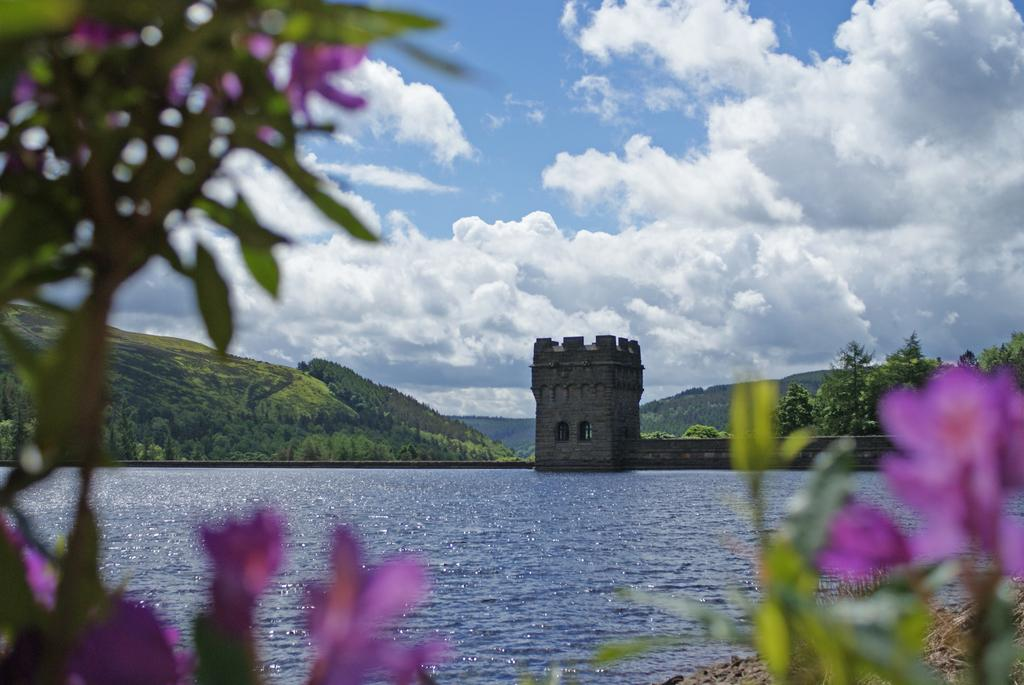What is the primary element visible in the image? There is water in the image. What types of plants can be seen in the foreground? There are flowers and leaves in the foreground. What type of landscape can be seen in the background? There are mountains in the background. Are there any man-made structures visible in the image? Yes, there is a building in the background. What is visible at the top of the image? The sky is visible at the top of the image. Where is the coal mine located in the image? There is no coal mine present in the image. What type of wind can be seen blowing through the flowers in the image? There is no wind visible in the image, and the term "zephyr" refers to a gentle breeze, which cannot be seen. 